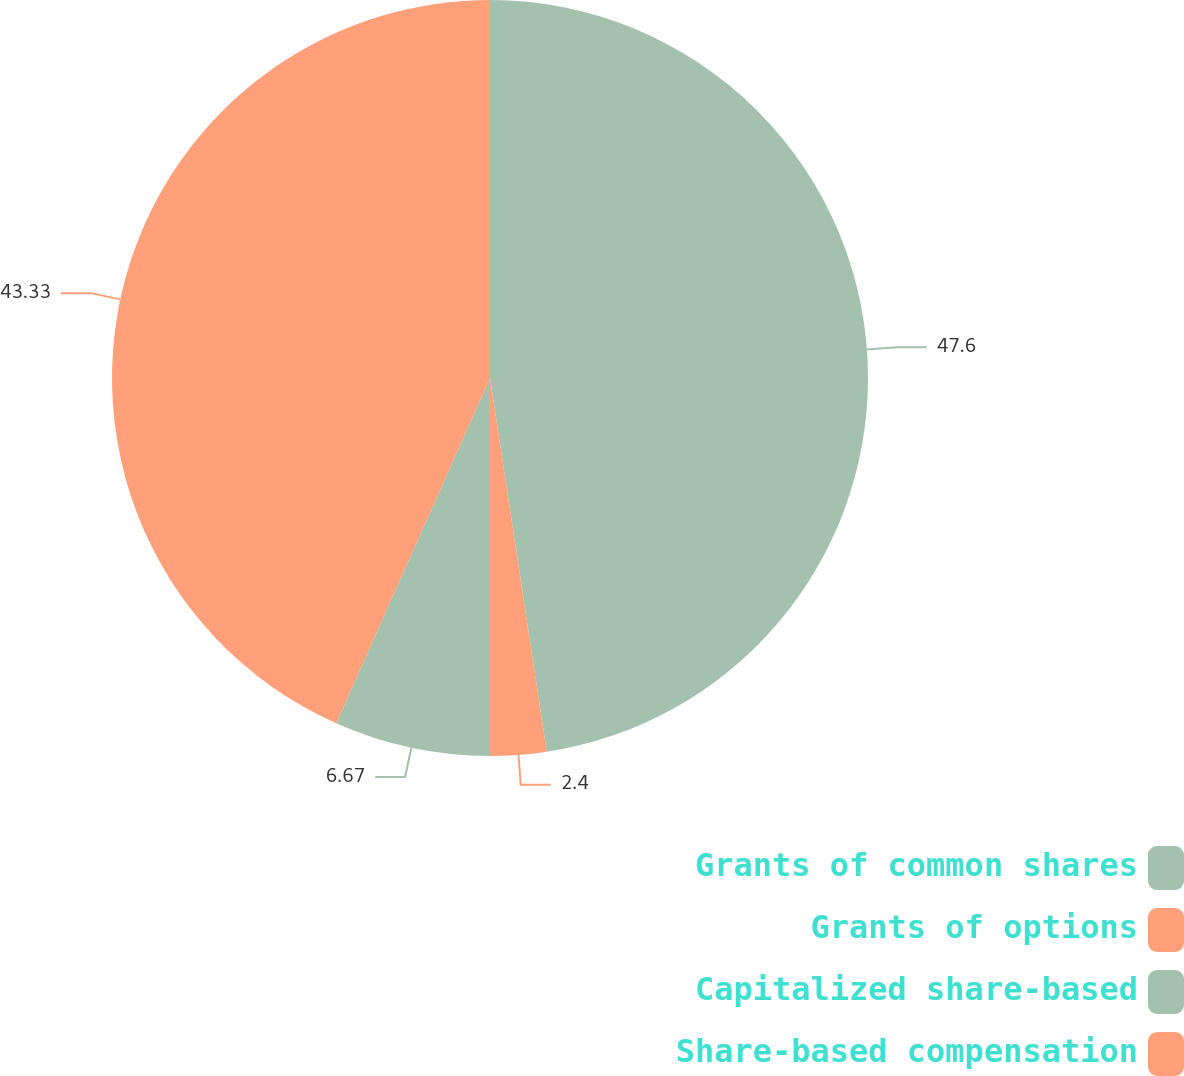<chart> <loc_0><loc_0><loc_500><loc_500><pie_chart><fcel>Grants of common shares<fcel>Grants of options<fcel>Capitalized share-based<fcel>Share-based compensation<nl><fcel>47.6%<fcel>2.4%<fcel>6.67%<fcel>43.33%<nl></chart> 